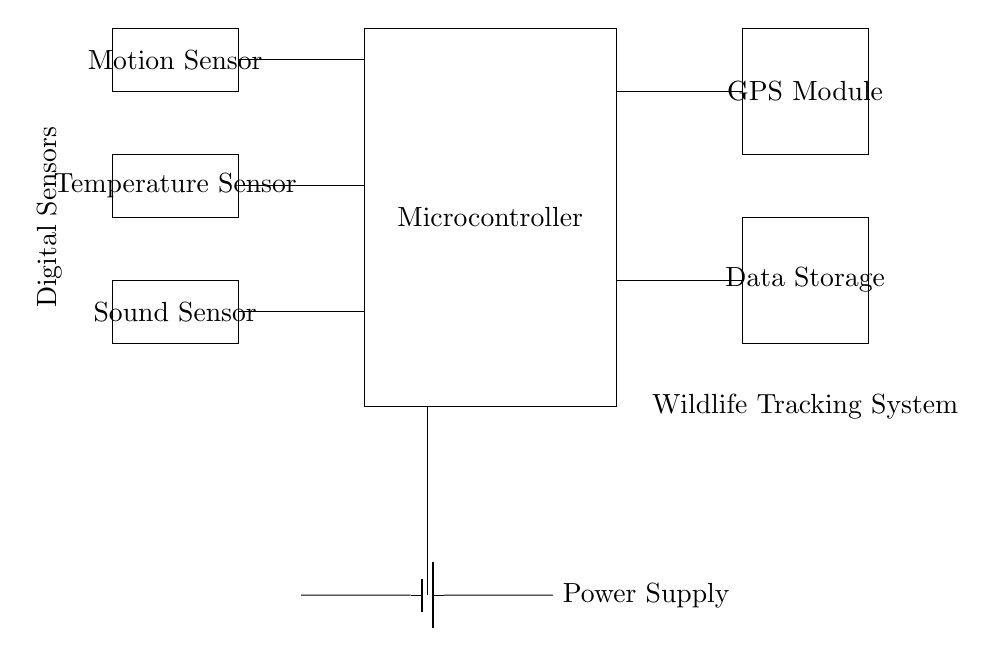What are the types of sensors shown? The circuit diagram indicates three types of sensors: a motion sensor, a temperature sensor, and a sound sensor. These are essential components of the wildlife tracking system designed to gather data about the environment and animal behavior.
Answer: motion sensor, temperature sensor, sound sensor How many sensors are connected to the microcontroller? There are three sensors connected to the microcontroller, as visually represented in the circuit with three lines linking the sensors to the microcontroller. Each connection signifies the flow of information from the sensors to the central processing unit.
Answer: three What is the power supply used in this circuit? The circuit features a battery as its power supply. The diagram illustrates the battery providing the necessary voltage and current to power all components in the wildlife tracking system.
Answer: battery How many data storage units are present? There is one data storage unit in the circuit diagram, represented by a single rectangle within the layout, indicating that the system collects and stores data from the sensors.
Answer: one What is the purpose of the GPS module in the system? The GPS module is responsible for tracking the geographical location of the wildlife. This enables the system to monitor animal movements and habitats, which is essential for ecological studies.
Answer: tracking location Which component communicates with the GPS module? The microcontroller communicates with the GPS module. In the circuit diagram, a line connects the microcontroller to the GPS module, indicating that the microcontroller processes data and coordinates from the GPS for further actions or storage.
Answer: microcontroller What is the function of the motion sensor? The motion sensor detects movement, which is crucial for understanding animal behavior in response to urban pollution and disturbances. It serves as a primary input for identifying animal activity in the environment.
Answer: detects movement 